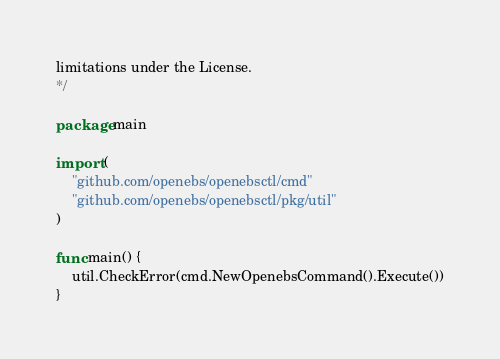Convert code to text. <code><loc_0><loc_0><loc_500><loc_500><_Go_>limitations under the License.
*/

package main

import (
	"github.com/openebs/openebsctl/cmd"
	"github.com/openebs/openebsctl/pkg/util"
)

func main() {
	util.CheckError(cmd.NewOpenebsCommand().Execute())
}
</code> 